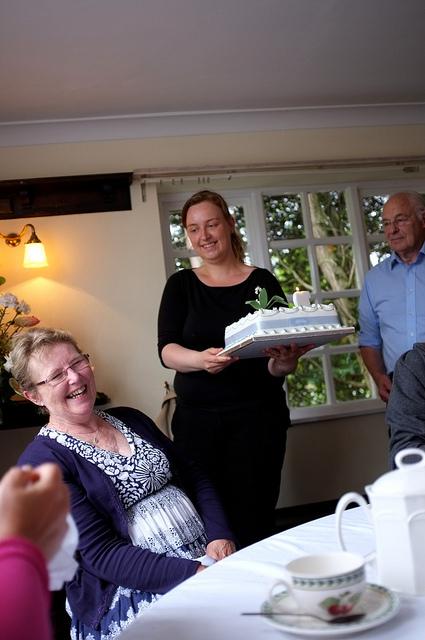What song would be appropriate for this occasion?
Quick response, please. Happy birthday. What kind of cup is in the picture?
Concise answer only. Tea cup. What is the object outside the window?
Answer briefly. Tree. 